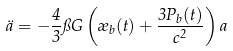<formula> <loc_0><loc_0><loc_500><loc_500>\ddot { a } = - \frac { 4 } { 3 } \pi G \left ( \rho _ { b } ( t ) + \frac { 3 P _ { b } ( t ) } { c ^ { 2 } } \right ) a</formula> 